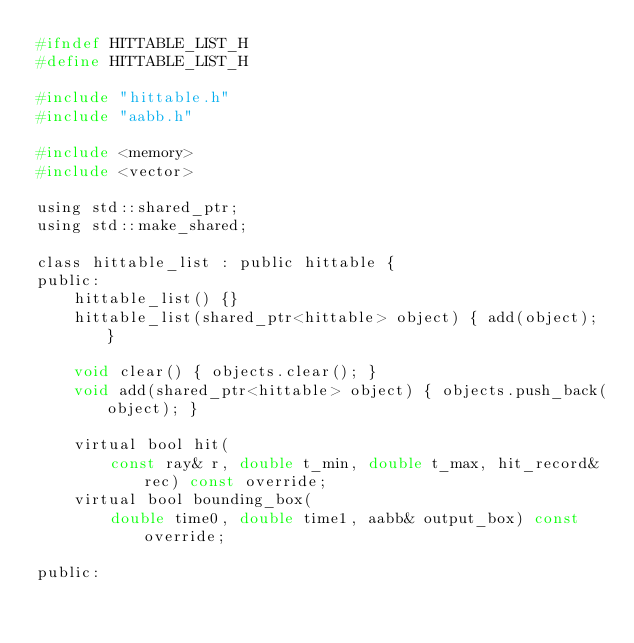Convert code to text. <code><loc_0><loc_0><loc_500><loc_500><_C_>#ifndef HITTABLE_LIST_H
#define HITTABLE_LIST_H

#include "hittable.h"
#include "aabb.h"

#include <memory>
#include <vector>

using std::shared_ptr;
using std::make_shared;

class hittable_list : public hittable {
public:
    hittable_list() {}
    hittable_list(shared_ptr<hittable> object) { add(object); }

    void clear() { objects.clear(); }
    void add(shared_ptr<hittable> object) { objects.push_back(object); }

    virtual bool hit(
        const ray& r, double t_min, double t_max, hit_record& rec) const override;
    virtual bool bounding_box(
        double time0, double time1, aabb& output_box) const override;

public:</code> 